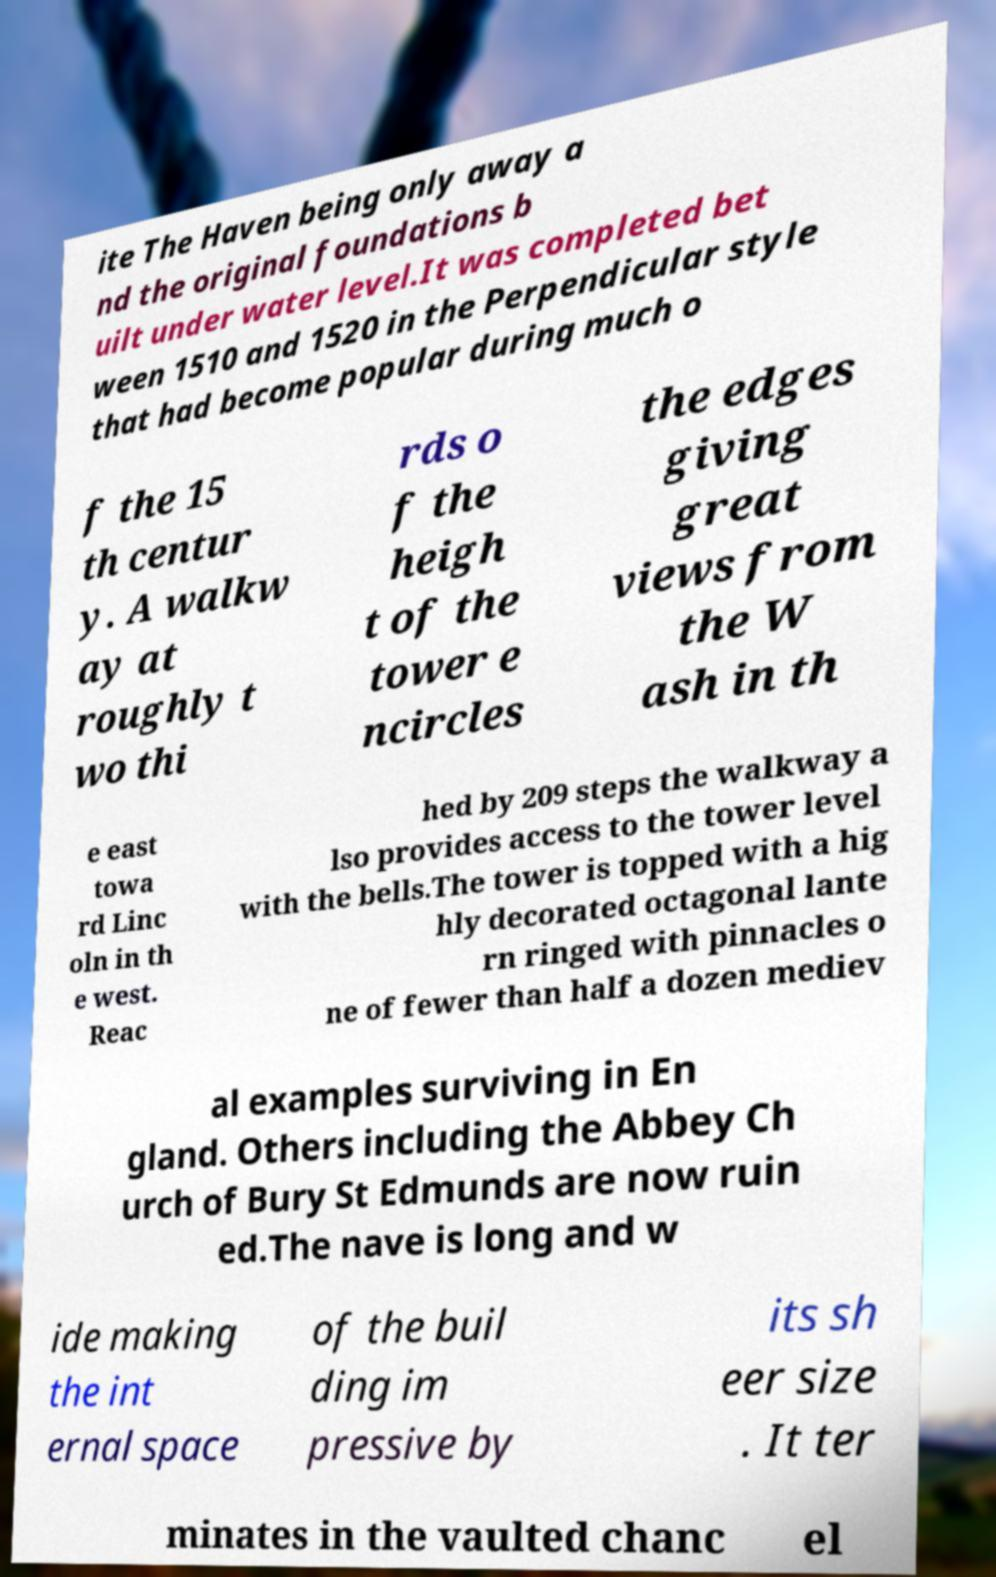What messages or text are displayed in this image? I need them in a readable, typed format. ite The Haven being only away a nd the original foundations b uilt under water level.It was completed bet ween 1510 and 1520 in the Perpendicular style that had become popular during much o f the 15 th centur y. A walkw ay at roughly t wo thi rds o f the heigh t of the tower e ncircles the edges giving great views from the W ash in th e east towa rd Linc oln in th e west. Reac hed by 209 steps the walkway a lso provides access to the tower level with the bells.The tower is topped with a hig hly decorated octagonal lante rn ringed with pinnacles o ne of fewer than half a dozen mediev al examples surviving in En gland. Others including the Abbey Ch urch of Bury St Edmunds are now ruin ed.The nave is long and w ide making the int ernal space of the buil ding im pressive by its sh eer size . It ter minates in the vaulted chanc el 